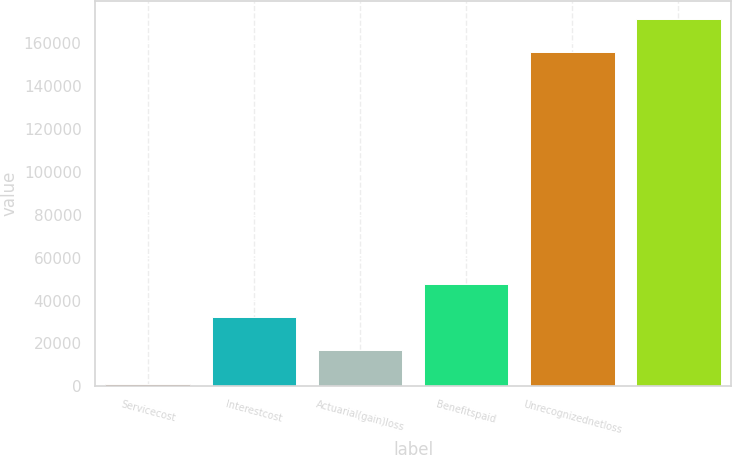<chart> <loc_0><loc_0><loc_500><loc_500><bar_chart><fcel>Servicecost<fcel>Interestcost<fcel>Actuarial(gain)loss<fcel>Benefitspaid<fcel>Unrecognizednetloss<fcel>Unnamed: 5<nl><fcel>1300<fcel>32205.8<fcel>16752.9<fcel>47658.7<fcel>155829<fcel>171282<nl></chart> 